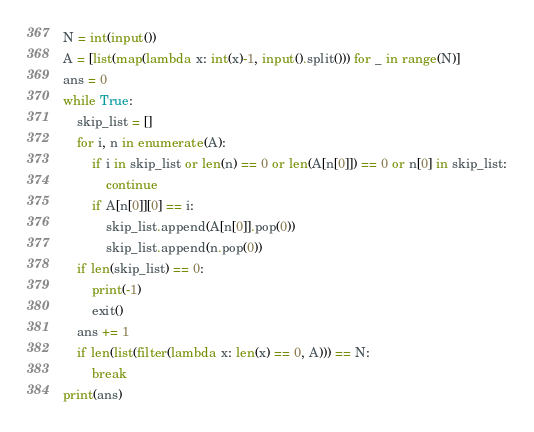<code> <loc_0><loc_0><loc_500><loc_500><_Python_>N = int(input())
A = [list(map(lambda x: int(x)-1, input().split())) for _ in range(N)]
ans = 0
while True:
    skip_list = []
    for i, n in enumerate(A):
        if i in skip_list or len(n) == 0 or len(A[n[0]]) == 0 or n[0] in skip_list:
            continue
        if A[n[0]][0] == i:
            skip_list.append(A[n[0]].pop(0))
            skip_list.append(n.pop(0))
    if len(skip_list) == 0:
        print(-1)
        exit()
    ans += 1
    if len(list(filter(lambda x: len(x) == 0, A))) == N:
        break
print(ans)
</code> 